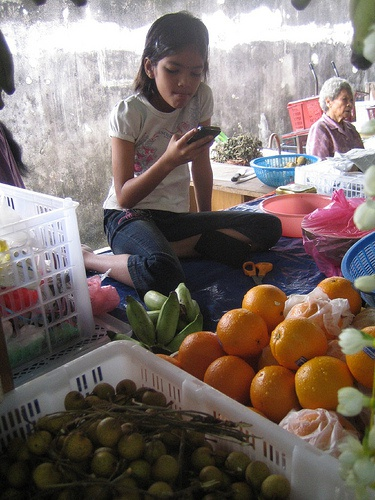Describe the objects in this image and their specific colors. I can see people in darkgray, black, gray, and maroon tones, orange in darkgray, maroon, brown, and black tones, people in darkgray, gray, white, and lightpink tones, orange in darkgray, maroon, gray, and brown tones, and orange in darkgray, brown, and maroon tones in this image. 